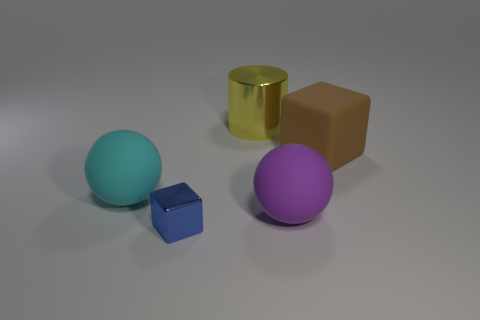What shapes are present in the scene besides spheres? Aside from the two spheres, there is a cube and a block, which have flat faces and edges, and a cylinder with curved surfaces. Do these objects look like they're made of the same material? Not quite. The cylinder has a reflective, possibly metallic surface, whereas the other objects have a rubbery look with more diffuse reflections. 